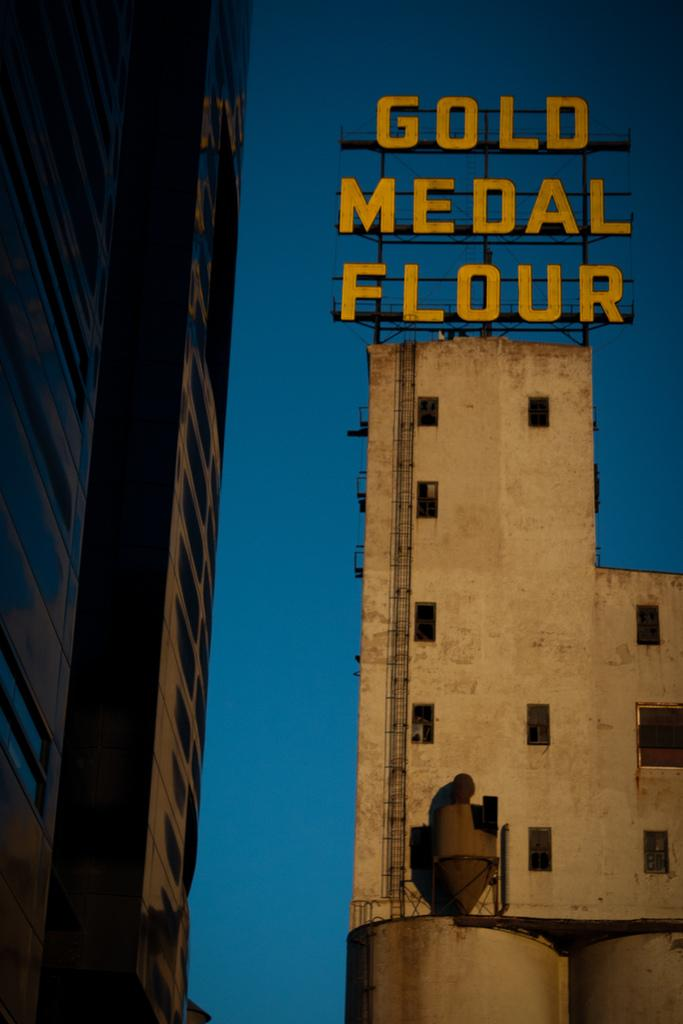What type of structures can be seen in the image? There are buildings in the image. Can you identify any specific features on the buildings? Yes, there appears to be a chimney in the image. Is there any text or signage visible on the buildings? Yes, there is a name board on top of a building. What can be seen in the background of the image? The sky is visible in the background of the image. Where is the sofa located in the image? There is no sofa present in the image. What type of list can be seen on the chimney in the image? There is no list present on the chimney in the image. 